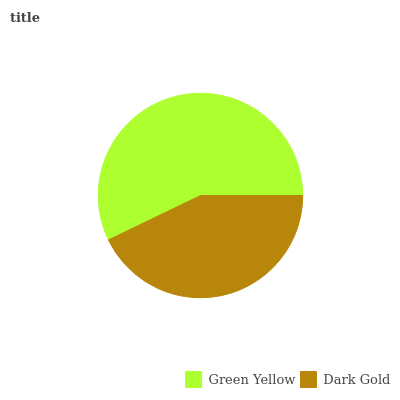Is Dark Gold the minimum?
Answer yes or no. Yes. Is Green Yellow the maximum?
Answer yes or no. Yes. Is Dark Gold the maximum?
Answer yes or no. No. Is Green Yellow greater than Dark Gold?
Answer yes or no. Yes. Is Dark Gold less than Green Yellow?
Answer yes or no. Yes. Is Dark Gold greater than Green Yellow?
Answer yes or no. No. Is Green Yellow less than Dark Gold?
Answer yes or no. No. Is Green Yellow the high median?
Answer yes or no. Yes. Is Dark Gold the low median?
Answer yes or no. Yes. Is Dark Gold the high median?
Answer yes or no. No. Is Green Yellow the low median?
Answer yes or no. No. 